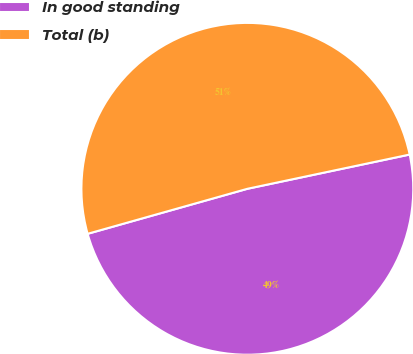Convert chart. <chart><loc_0><loc_0><loc_500><loc_500><pie_chart><fcel>In good standing<fcel>Total (b)<nl><fcel>48.94%<fcel>51.06%<nl></chart> 